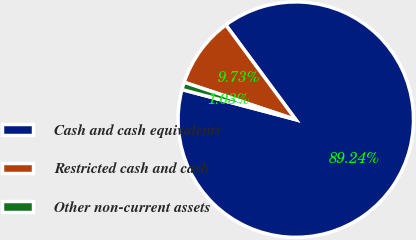Convert chart. <chart><loc_0><loc_0><loc_500><loc_500><pie_chart><fcel>Cash and cash equivalents<fcel>Restricted cash and cash<fcel>Other non-current assets<nl><fcel>89.24%<fcel>9.73%<fcel>1.03%<nl></chart> 